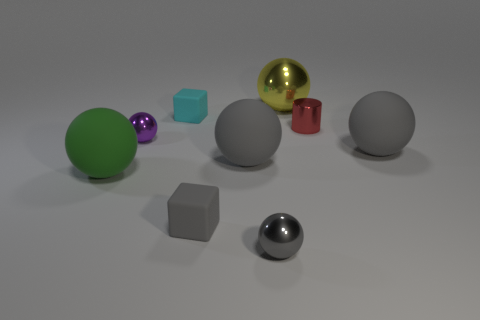Add 1 metallic spheres. How many objects exist? 10 Subtract all big yellow shiny balls. How many balls are left? 5 Subtract all cylinders. How many objects are left? 8 Subtract 1 cylinders. How many cylinders are left? 0 Subtract all cyan blocks. How many blocks are left? 1 Add 3 yellow spheres. How many yellow spheres are left? 4 Add 2 big rubber cubes. How many big rubber cubes exist? 2 Subtract 1 gray balls. How many objects are left? 8 Subtract all gray cylinders. Subtract all yellow balls. How many cylinders are left? 1 Subtract all red balls. How many cyan cubes are left? 1 